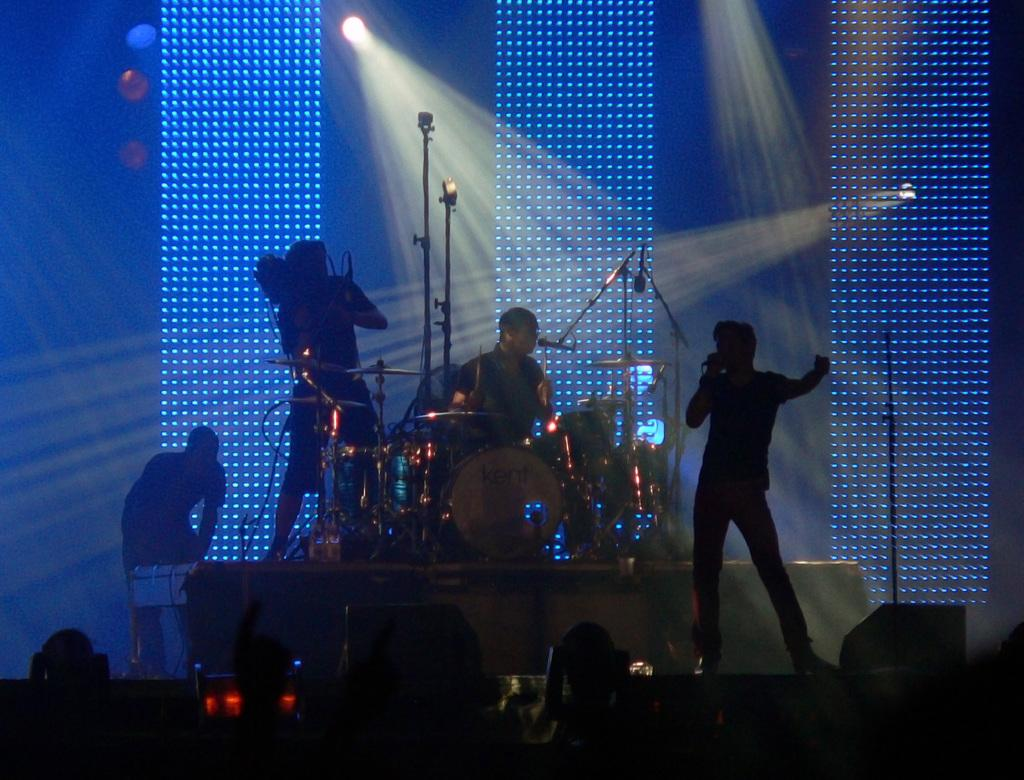What is the man in the image doing? The man is standing and singing a song in the image. Are there any other people in the image? Yes, there is another man beating drums in the image. What can be seen in the background of the image? There are lights visible in the background of the image. What type of berry is the woman holding in the image? There is no woman or berry present in the image. What is the man talking about while singing in the image? The provided facts do not mention what the man is singing about, so we cannot determine the topic of his song. 